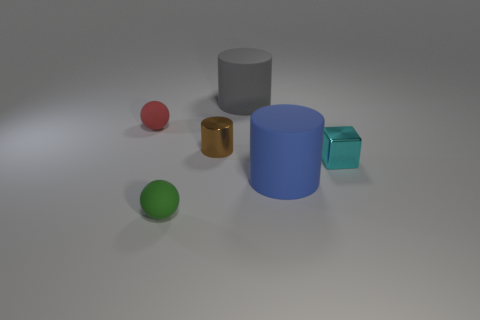There is a big blue matte object; does it have the same shape as the tiny matte thing in front of the red thing?
Your answer should be very brief. No. There is a large rubber thing in front of the brown cylinder; what color is it?
Give a very brief answer. Blue. There is a metallic thing that is to the left of the large rubber cylinder behind the red rubber sphere; what is its size?
Offer a very short reply. Small. There is a small metallic thing on the left side of the tiny cyan thing; is it the same shape as the big gray matte object?
Your answer should be compact. Yes. There is another thing that is the same shape as the red rubber thing; what material is it?
Your answer should be compact. Rubber. How many things are either small rubber objects behind the small cyan cube or metallic objects that are behind the big blue cylinder?
Give a very brief answer. 3. There is a brown object that is made of the same material as the tiny cube; what is its shape?
Give a very brief answer. Cylinder. What number of objects are there?
Your response must be concise. 6. What number of things are either things that are in front of the big gray matte object or big purple metallic cubes?
Provide a short and direct response. 5. How many other objects are there of the same color as the small cylinder?
Give a very brief answer. 0. 